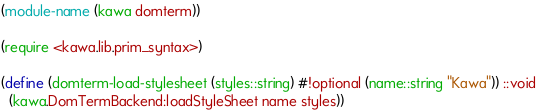<code> <loc_0><loc_0><loc_500><loc_500><_Scheme_>(module-name (kawa domterm))

(require <kawa.lib.prim_syntax>)

(define (domterm-load-stylesheet (styles::string) #!optional (name::string "Kawa")) ::void
  (kawa.DomTermBackend:loadStyleSheet name styles))
</code> 